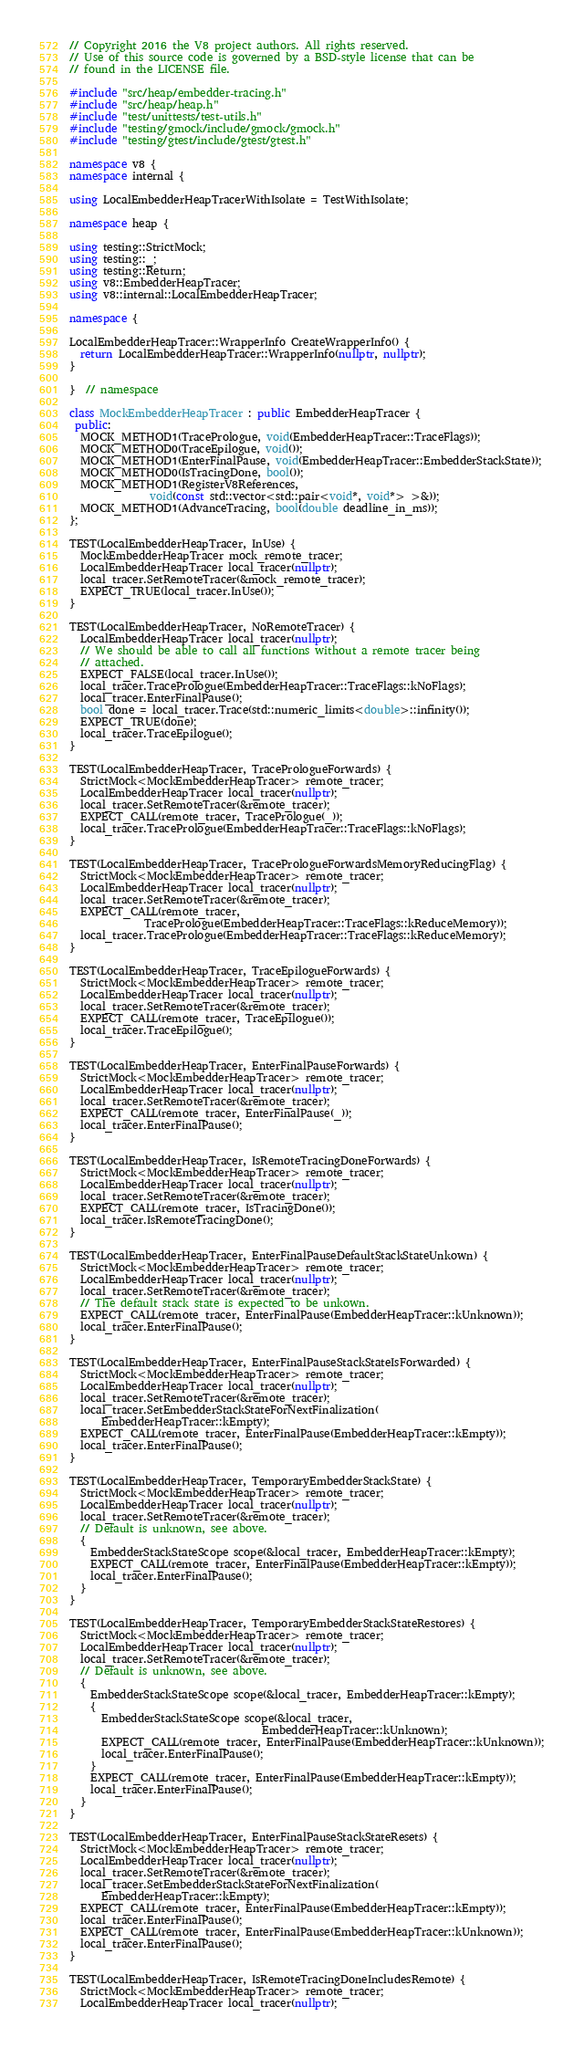Convert code to text. <code><loc_0><loc_0><loc_500><loc_500><_C++_>// Copyright 2016 the V8 project authors. All rights reserved.
// Use of this source code is governed by a BSD-style license that can be
// found in the LICENSE file.

#include "src/heap/embedder-tracing.h"
#include "src/heap/heap.h"
#include "test/unittests/test-utils.h"
#include "testing/gmock/include/gmock/gmock.h"
#include "testing/gtest/include/gtest/gtest.h"

namespace v8 {
namespace internal {

using LocalEmbedderHeapTracerWithIsolate = TestWithIsolate;

namespace heap {

using testing::StrictMock;
using testing::_;
using testing::Return;
using v8::EmbedderHeapTracer;
using v8::internal::LocalEmbedderHeapTracer;

namespace {

LocalEmbedderHeapTracer::WrapperInfo CreateWrapperInfo() {
  return LocalEmbedderHeapTracer::WrapperInfo(nullptr, nullptr);
}

}  // namespace

class MockEmbedderHeapTracer : public EmbedderHeapTracer {
 public:
  MOCK_METHOD1(TracePrologue, void(EmbedderHeapTracer::TraceFlags));
  MOCK_METHOD0(TraceEpilogue, void());
  MOCK_METHOD1(EnterFinalPause, void(EmbedderHeapTracer::EmbedderStackState));
  MOCK_METHOD0(IsTracingDone, bool());
  MOCK_METHOD1(RegisterV8References,
               void(const std::vector<std::pair<void*, void*> >&));
  MOCK_METHOD1(AdvanceTracing, bool(double deadline_in_ms));
};

TEST(LocalEmbedderHeapTracer, InUse) {
  MockEmbedderHeapTracer mock_remote_tracer;
  LocalEmbedderHeapTracer local_tracer(nullptr);
  local_tracer.SetRemoteTracer(&mock_remote_tracer);
  EXPECT_TRUE(local_tracer.InUse());
}

TEST(LocalEmbedderHeapTracer, NoRemoteTracer) {
  LocalEmbedderHeapTracer local_tracer(nullptr);
  // We should be able to call all functions without a remote tracer being
  // attached.
  EXPECT_FALSE(local_tracer.InUse());
  local_tracer.TracePrologue(EmbedderHeapTracer::TraceFlags::kNoFlags);
  local_tracer.EnterFinalPause();
  bool done = local_tracer.Trace(std::numeric_limits<double>::infinity());
  EXPECT_TRUE(done);
  local_tracer.TraceEpilogue();
}

TEST(LocalEmbedderHeapTracer, TracePrologueForwards) {
  StrictMock<MockEmbedderHeapTracer> remote_tracer;
  LocalEmbedderHeapTracer local_tracer(nullptr);
  local_tracer.SetRemoteTracer(&remote_tracer);
  EXPECT_CALL(remote_tracer, TracePrologue(_));
  local_tracer.TracePrologue(EmbedderHeapTracer::TraceFlags::kNoFlags);
}

TEST(LocalEmbedderHeapTracer, TracePrologueForwardsMemoryReducingFlag) {
  StrictMock<MockEmbedderHeapTracer> remote_tracer;
  LocalEmbedderHeapTracer local_tracer(nullptr);
  local_tracer.SetRemoteTracer(&remote_tracer);
  EXPECT_CALL(remote_tracer,
              TracePrologue(EmbedderHeapTracer::TraceFlags::kReduceMemory));
  local_tracer.TracePrologue(EmbedderHeapTracer::TraceFlags::kReduceMemory);
}

TEST(LocalEmbedderHeapTracer, TraceEpilogueForwards) {
  StrictMock<MockEmbedderHeapTracer> remote_tracer;
  LocalEmbedderHeapTracer local_tracer(nullptr);
  local_tracer.SetRemoteTracer(&remote_tracer);
  EXPECT_CALL(remote_tracer, TraceEpilogue());
  local_tracer.TraceEpilogue();
}

TEST(LocalEmbedderHeapTracer, EnterFinalPauseForwards) {
  StrictMock<MockEmbedderHeapTracer> remote_tracer;
  LocalEmbedderHeapTracer local_tracer(nullptr);
  local_tracer.SetRemoteTracer(&remote_tracer);
  EXPECT_CALL(remote_tracer, EnterFinalPause(_));
  local_tracer.EnterFinalPause();
}

TEST(LocalEmbedderHeapTracer, IsRemoteTracingDoneForwards) {
  StrictMock<MockEmbedderHeapTracer> remote_tracer;
  LocalEmbedderHeapTracer local_tracer(nullptr);
  local_tracer.SetRemoteTracer(&remote_tracer);
  EXPECT_CALL(remote_tracer, IsTracingDone());
  local_tracer.IsRemoteTracingDone();
}

TEST(LocalEmbedderHeapTracer, EnterFinalPauseDefaultStackStateUnkown) {
  StrictMock<MockEmbedderHeapTracer> remote_tracer;
  LocalEmbedderHeapTracer local_tracer(nullptr);
  local_tracer.SetRemoteTracer(&remote_tracer);
  // The default stack state is expected to be unkown.
  EXPECT_CALL(remote_tracer, EnterFinalPause(EmbedderHeapTracer::kUnknown));
  local_tracer.EnterFinalPause();
}

TEST(LocalEmbedderHeapTracer, EnterFinalPauseStackStateIsForwarded) {
  StrictMock<MockEmbedderHeapTracer> remote_tracer;
  LocalEmbedderHeapTracer local_tracer(nullptr);
  local_tracer.SetRemoteTracer(&remote_tracer);
  local_tracer.SetEmbedderStackStateForNextFinalization(
      EmbedderHeapTracer::kEmpty);
  EXPECT_CALL(remote_tracer, EnterFinalPause(EmbedderHeapTracer::kEmpty));
  local_tracer.EnterFinalPause();
}

TEST(LocalEmbedderHeapTracer, TemporaryEmbedderStackState) {
  StrictMock<MockEmbedderHeapTracer> remote_tracer;
  LocalEmbedderHeapTracer local_tracer(nullptr);
  local_tracer.SetRemoteTracer(&remote_tracer);
  // Default is unknown, see above.
  {
    EmbedderStackStateScope scope(&local_tracer, EmbedderHeapTracer::kEmpty);
    EXPECT_CALL(remote_tracer, EnterFinalPause(EmbedderHeapTracer::kEmpty));
    local_tracer.EnterFinalPause();
  }
}

TEST(LocalEmbedderHeapTracer, TemporaryEmbedderStackStateRestores) {
  StrictMock<MockEmbedderHeapTracer> remote_tracer;
  LocalEmbedderHeapTracer local_tracer(nullptr);
  local_tracer.SetRemoteTracer(&remote_tracer);
  // Default is unknown, see above.
  {
    EmbedderStackStateScope scope(&local_tracer, EmbedderHeapTracer::kEmpty);
    {
      EmbedderStackStateScope scope(&local_tracer,
                                    EmbedderHeapTracer::kUnknown);
      EXPECT_CALL(remote_tracer, EnterFinalPause(EmbedderHeapTracer::kUnknown));
      local_tracer.EnterFinalPause();
    }
    EXPECT_CALL(remote_tracer, EnterFinalPause(EmbedderHeapTracer::kEmpty));
    local_tracer.EnterFinalPause();
  }
}

TEST(LocalEmbedderHeapTracer, EnterFinalPauseStackStateResets) {
  StrictMock<MockEmbedderHeapTracer> remote_tracer;
  LocalEmbedderHeapTracer local_tracer(nullptr);
  local_tracer.SetRemoteTracer(&remote_tracer);
  local_tracer.SetEmbedderStackStateForNextFinalization(
      EmbedderHeapTracer::kEmpty);
  EXPECT_CALL(remote_tracer, EnterFinalPause(EmbedderHeapTracer::kEmpty));
  local_tracer.EnterFinalPause();
  EXPECT_CALL(remote_tracer, EnterFinalPause(EmbedderHeapTracer::kUnknown));
  local_tracer.EnterFinalPause();
}

TEST(LocalEmbedderHeapTracer, IsRemoteTracingDoneIncludesRemote) {
  StrictMock<MockEmbedderHeapTracer> remote_tracer;
  LocalEmbedderHeapTracer local_tracer(nullptr);</code> 